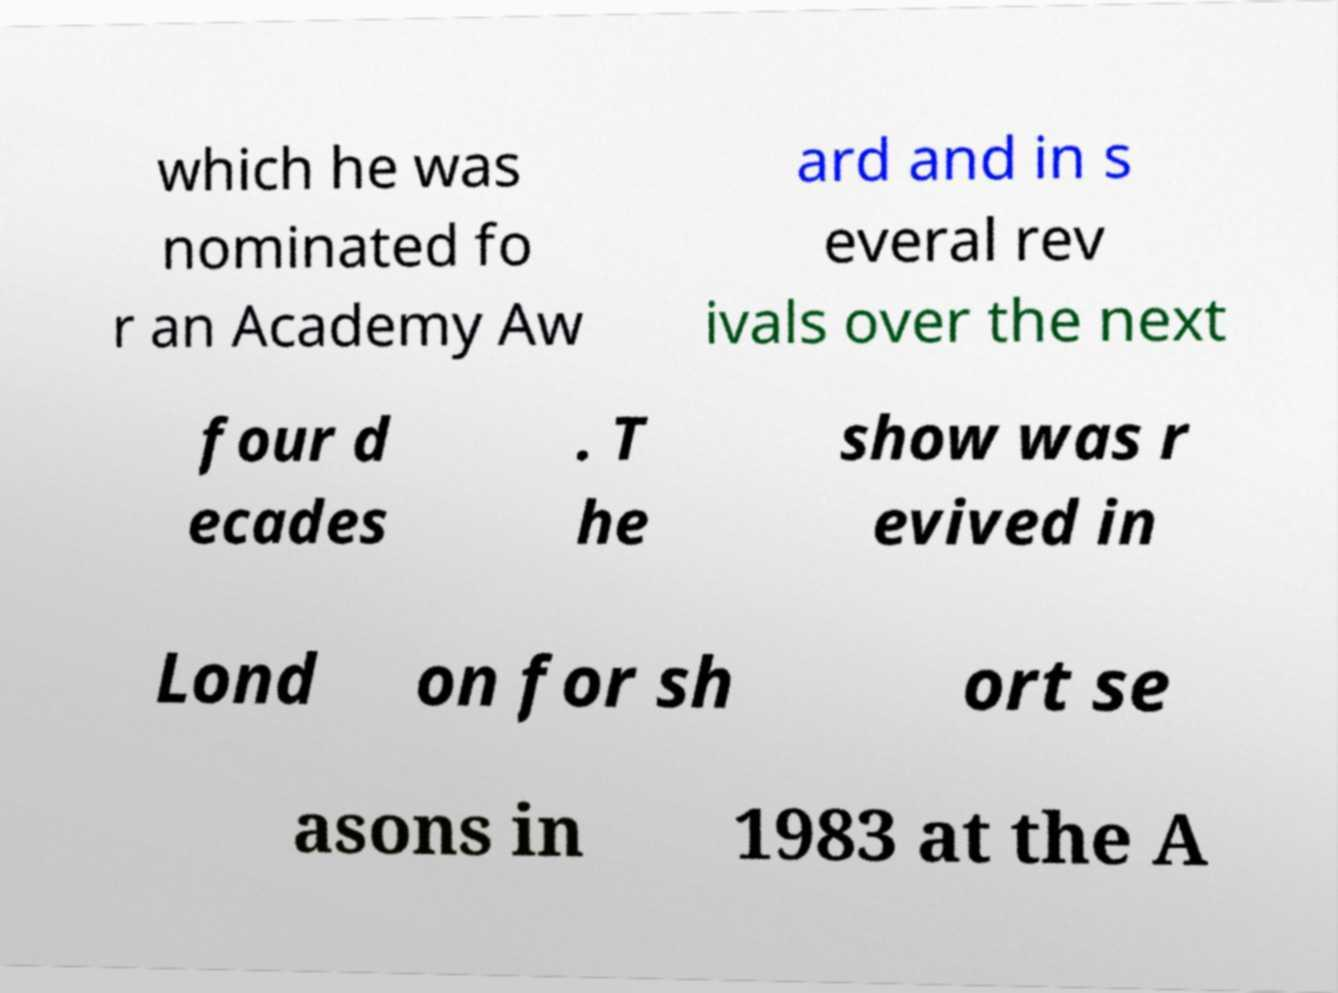What messages or text are displayed in this image? I need them in a readable, typed format. which he was nominated fo r an Academy Aw ard and in s everal rev ivals over the next four d ecades . T he show was r evived in Lond on for sh ort se asons in 1983 at the A 